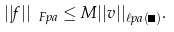Convert formula to latex. <formula><loc_0><loc_0><loc_500><loc_500>| | f | | _ { \ F p a } \leq M | | v | | _ { \ell p a ( \Lambda ) } .</formula> 